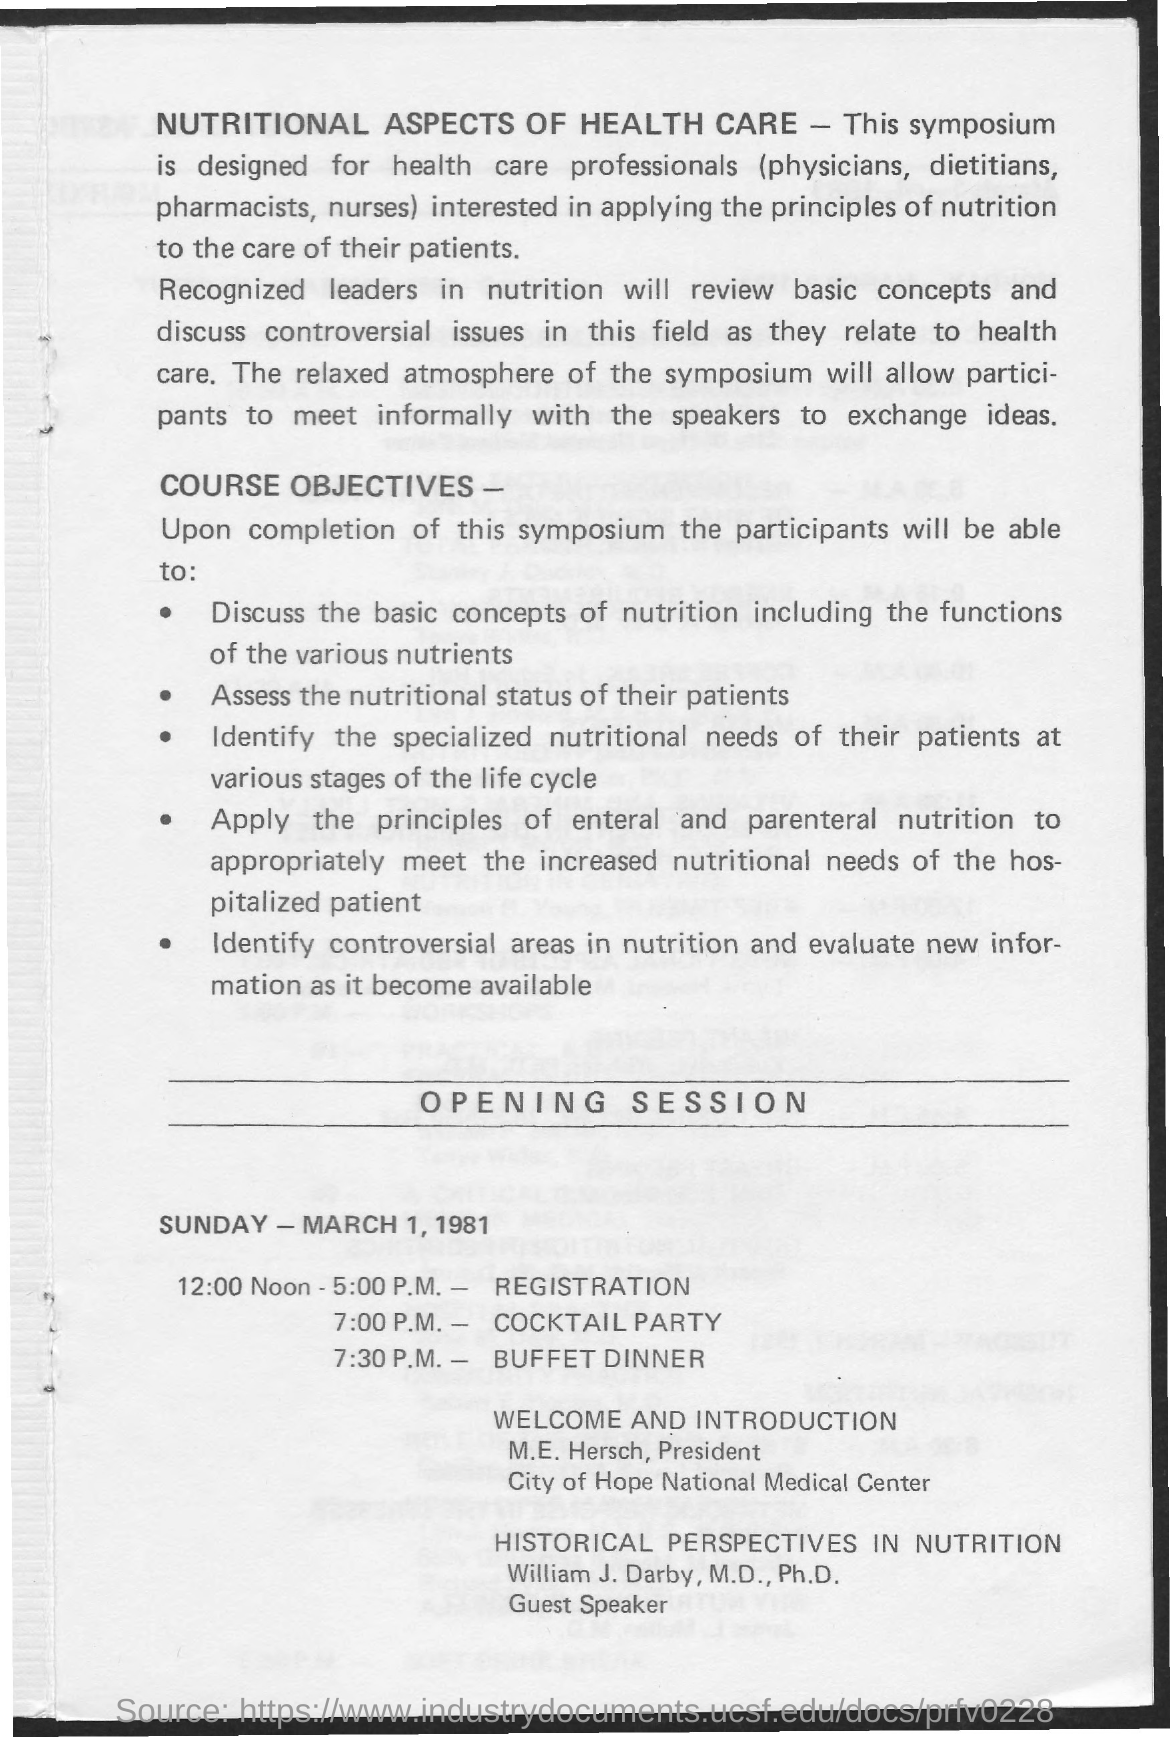Specify some key components in this picture. The guest speaker is Dr. William J. Darby, M.D., Ph.D. The president of City of Hope National Medical Center is M.E. Hersch. In the opening session, it is mentioned that Sunday is the day of the week. The time for registration is scheduled to begin at 12:00 noon and end at 5:00 PM. The heading of the page is 'Nutritional Aspects of Health Care,' which highlights the importance of proper nutrition in maintaining good health. 